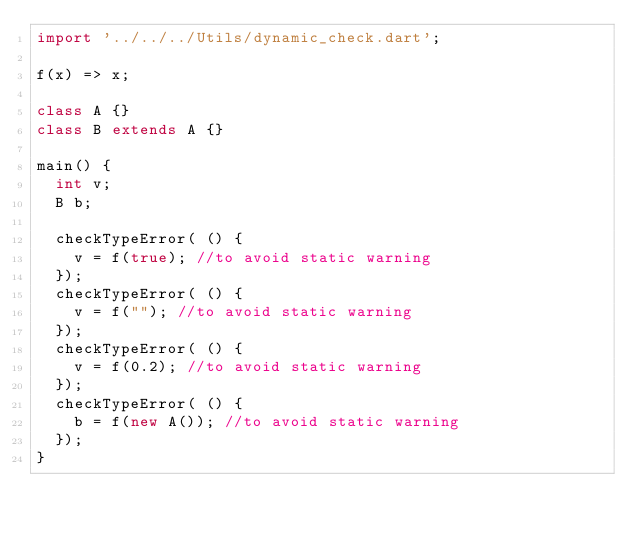Convert code to text. <code><loc_0><loc_0><loc_500><loc_500><_Dart_>import '../../../Utils/dynamic_check.dart';

f(x) => x;

class A {}
class B extends A {}

main() {
  int v;
  B b;

  checkTypeError( () {
    v = f(true); //to avoid static warning
  });
  checkTypeError( () {
    v = f(""); //to avoid static warning
  });
  checkTypeError( () {
    v = f(0.2); //to avoid static warning
  });
  checkTypeError( () {
    b = f(new A()); //to avoid static warning
  });
}
</code> 